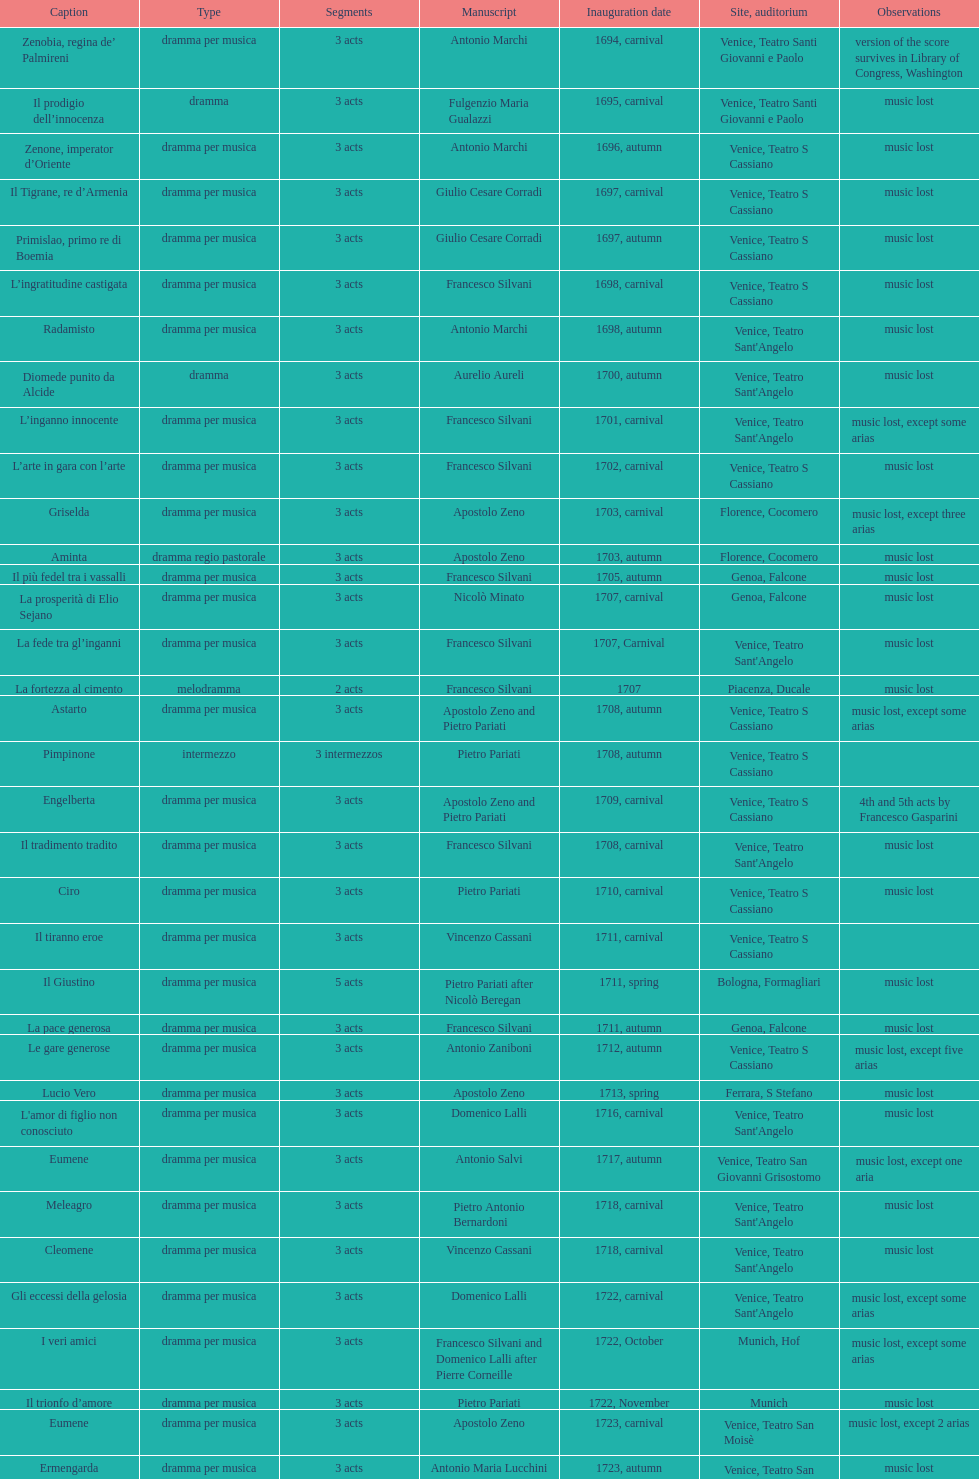Which opera has the most acts, la fortezza al cimento or astarto? Astarto. 